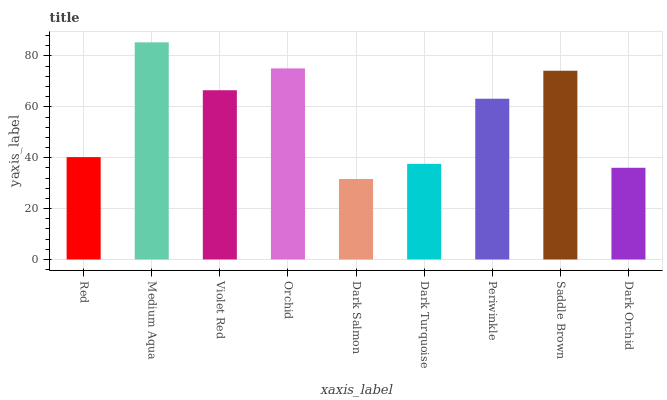Is Dark Salmon the minimum?
Answer yes or no. Yes. Is Medium Aqua the maximum?
Answer yes or no. Yes. Is Violet Red the minimum?
Answer yes or no. No. Is Violet Red the maximum?
Answer yes or no. No. Is Medium Aqua greater than Violet Red?
Answer yes or no. Yes. Is Violet Red less than Medium Aqua?
Answer yes or no. Yes. Is Violet Red greater than Medium Aqua?
Answer yes or no. No. Is Medium Aqua less than Violet Red?
Answer yes or no. No. Is Periwinkle the high median?
Answer yes or no. Yes. Is Periwinkle the low median?
Answer yes or no. Yes. Is Dark Orchid the high median?
Answer yes or no. No. Is Orchid the low median?
Answer yes or no. No. 